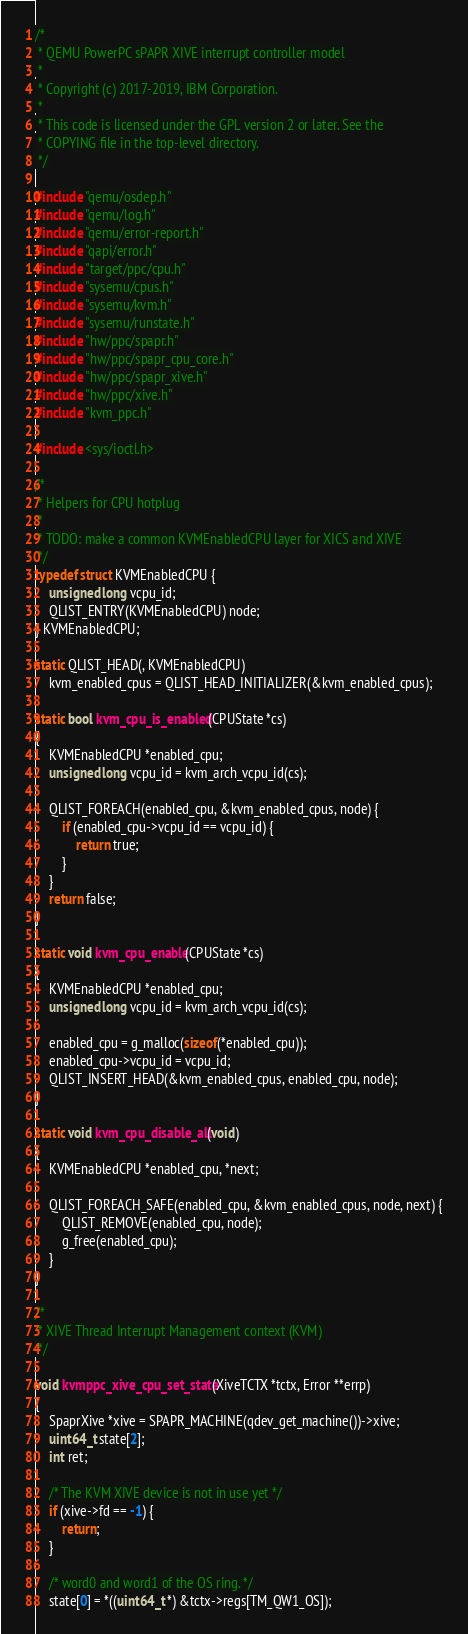Convert code to text. <code><loc_0><loc_0><loc_500><loc_500><_C_>/*
 * QEMU PowerPC sPAPR XIVE interrupt controller model
 *
 * Copyright (c) 2017-2019, IBM Corporation.
 *
 * This code is licensed under the GPL version 2 or later. See the
 * COPYING file in the top-level directory.
 */

#include "qemu/osdep.h"
#include "qemu/log.h"
#include "qemu/error-report.h"
#include "qapi/error.h"
#include "target/ppc/cpu.h"
#include "sysemu/cpus.h"
#include "sysemu/kvm.h"
#include "sysemu/runstate.h"
#include "hw/ppc/spapr.h"
#include "hw/ppc/spapr_cpu_core.h"
#include "hw/ppc/spapr_xive.h"
#include "hw/ppc/xive.h"
#include "kvm_ppc.h"

#include <sys/ioctl.h>

/*
 * Helpers for CPU hotplug
 *
 * TODO: make a common KVMEnabledCPU layer for XICS and XIVE
 */
typedef struct KVMEnabledCPU {
    unsigned long vcpu_id;
    QLIST_ENTRY(KVMEnabledCPU) node;
} KVMEnabledCPU;

static QLIST_HEAD(, KVMEnabledCPU)
    kvm_enabled_cpus = QLIST_HEAD_INITIALIZER(&kvm_enabled_cpus);

static bool kvm_cpu_is_enabled(CPUState *cs)
{
    KVMEnabledCPU *enabled_cpu;
    unsigned long vcpu_id = kvm_arch_vcpu_id(cs);

    QLIST_FOREACH(enabled_cpu, &kvm_enabled_cpus, node) {
        if (enabled_cpu->vcpu_id == vcpu_id) {
            return true;
        }
    }
    return false;
}

static void kvm_cpu_enable(CPUState *cs)
{
    KVMEnabledCPU *enabled_cpu;
    unsigned long vcpu_id = kvm_arch_vcpu_id(cs);

    enabled_cpu = g_malloc(sizeof(*enabled_cpu));
    enabled_cpu->vcpu_id = vcpu_id;
    QLIST_INSERT_HEAD(&kvm_enabled_cpus, enabled_cpu, node);
}

static void kvm_cpu_disable_all(void)
{
    KVMEnabledCPU *enabled_cpu, *next;

    QLIST_FOREACH_SAFE(enabled_cpu, &kvm_enabled_cpus, node, next) {
        QLIST_REMOVE(enabled_cpu, node);
        g_free(enabled_cpu);
    }
}

/*
 * XIVE Thread Interrupt Management context (KVM)
 */

void kvmppc_xive_cpu_set_state(XiveTCTX *tctx, Error **errp)
{
    SpaprXive *xive = SPAPR_MACHINE(qdev_get_machine())->xive;
    uint64_t state[2];
    int ret;

    /* The KVM XIVE device is not in use yet */
    if (xive->fd == -1) {
        return;
    }

    /* word0 and word1 of the OS ring. */
    state[0] = *((uint64_t *) &tctx->regs[TM_QW1_OS]);
</code> 